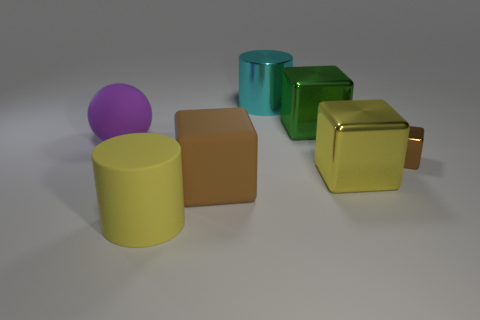Is there anything else that has the same size as the brown metal thing?
Provide a succinct answer. No. How many other cyan things have the same shape as the cyan shiny object?
Provide a short and direct response. 0. What is the shape of the cyan object that is the same material as the big yellow cube?
Your answer should be compact. Cylinder. There is a large shiny block that is in front of the thing left of the large yellow matte object; what color is it?
Provide a succinct answer. Yellow. Does the tiny cube have the same color as the rubber block?
Your answer should be compact. Yes. There is a object to the left of the big yellow thing in front of the brown rubber cube; what is its material?
Your answer should be very brief. Rubber. What is the material of the tiny object that is the same shape as the big brown matte thing?
Provide a succinct answer. Metal. There is a brown thing left of the big cylinder behind the tiny object; are there any large cylinders behind it?
Your answer should be very brief. Yes. How many other things are the same color as the rubber cube?
Give a very brief answer. 1. What number of large objects are both to the left of the large green metallic thing and right of the large purple object?
Make the answer very short. 3. 